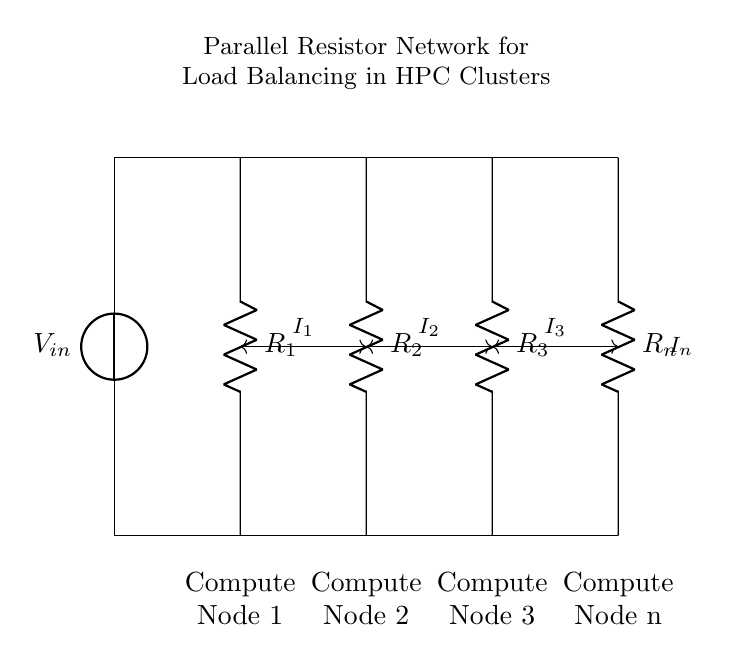What is the input voltage of the circuit? The input voltage is labeled as \( V_{in} \) in the circuit diagram. The value is not specified in the visual information, but it indicates the voltage supply to the parallel network.
Answer: \( V_{in} \) How many resistors are present in the circuit? The diagram shows four resistors labeled \( R_1, R_2, R_3, \) and \( R_n \), indicating that there are four resistors connected in parallel.
Answer: 4 Which compute node is closest to the voltage source? The compute node labeled as Compute Node 1 is directly below \( R_1 \), making it the closest node to the voltage source at the top of the circuit.
Answer: Compute Node 1 If \( R_1 \) = 2 ohms, \( R_2 \) = 3 ohms, \( R_3 \) = 4 ohms, and \( R_n \) = 6 ohms, what is the equivalent resistance \( R_{eq} \)? The equivalent resistance \( R_{eq} \) of resistors in parallel is calculated using the formula \( \frac{1}{R_{eq}} = \frac{1}{R_1} + \frac{1}{R_2} + \frac{1}{R_3} + \frac{1}{R_n} \). Substituting the values gives \( \frac{1}{R_{eq}} = \frac{1}{2} + \frac{1}{3} + \frac{1}{4} + \frac{1}{6} = \frac{13}{12} \), hence \( R_{eq} = \frac{12}{13} \) ohms.
Answer: 0.923 ohms Which node would experience the highest current if all resistors are equal? In a parallel resistor circuit with equal resistors, the current divides equally among them, and each node would experience the same current. Therefore, there is no specific node that experiences the highest current.
Answer: All nodes equally What is the purpose of using a parallel resistor network in HPC clusters? The parallel resistor network distributes the input current among different compute nodes to ensure load balancing across the network. This approach can minimize the risk of overloading any single node, thus enhancing overall performance and reliability of the system.
Answer: Load balancing 